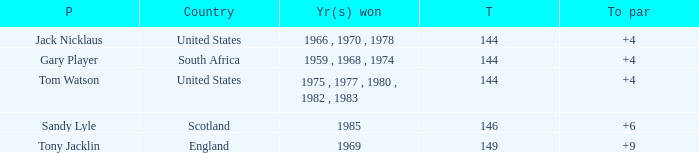What was england's overall sum? 149.0. 